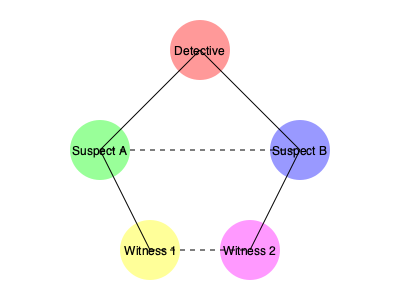In the given network diagram representing character relationships in a mystery novel, how many direct connections does the Detective have, and what might this suggest about their role in the investigation? To answer this question, we need to analyze the network diagram step-by-step:

1. Identify the Detective: The Detective is represented by the central node at the top of the diagram.

2. Count direct connections:
   - The Detective has a solid line connecting to Suspect A
   - The Detective has a solid line connecting to Suspect B
   - There are no direct connections between the Detective and the Witnesses

3. Tally the connections: The Detective has 2 direct connections.

4. Interpret the role:
   - The Detective is directly connected to both suspects, suggesting they are actively investigating these individuals.
   - The lack of direct connections to witnesses implies the Detective may be relying on indirect information or hasn't yet interviewed the witnesses directly.
   - The central position of the Detective node indicates their pivotal role in the investigation, acting as a hub between suspects.

5. Additional observations:
   - The dashed lines between suspects and between witnesses might represent known relationships or connections that the Detective is aware of but not directly involved in.
   - The Detective's position at the top of the diagram could symbolize their authority or oversight in the case.

This network structure suggests that the Detective is at the center of the investigation, directly engaging with suspects while potentially gathering information about witnesses indirectly or preparing to interview them later in the investigation.
Answer: 2 direct connections; central investigative role 